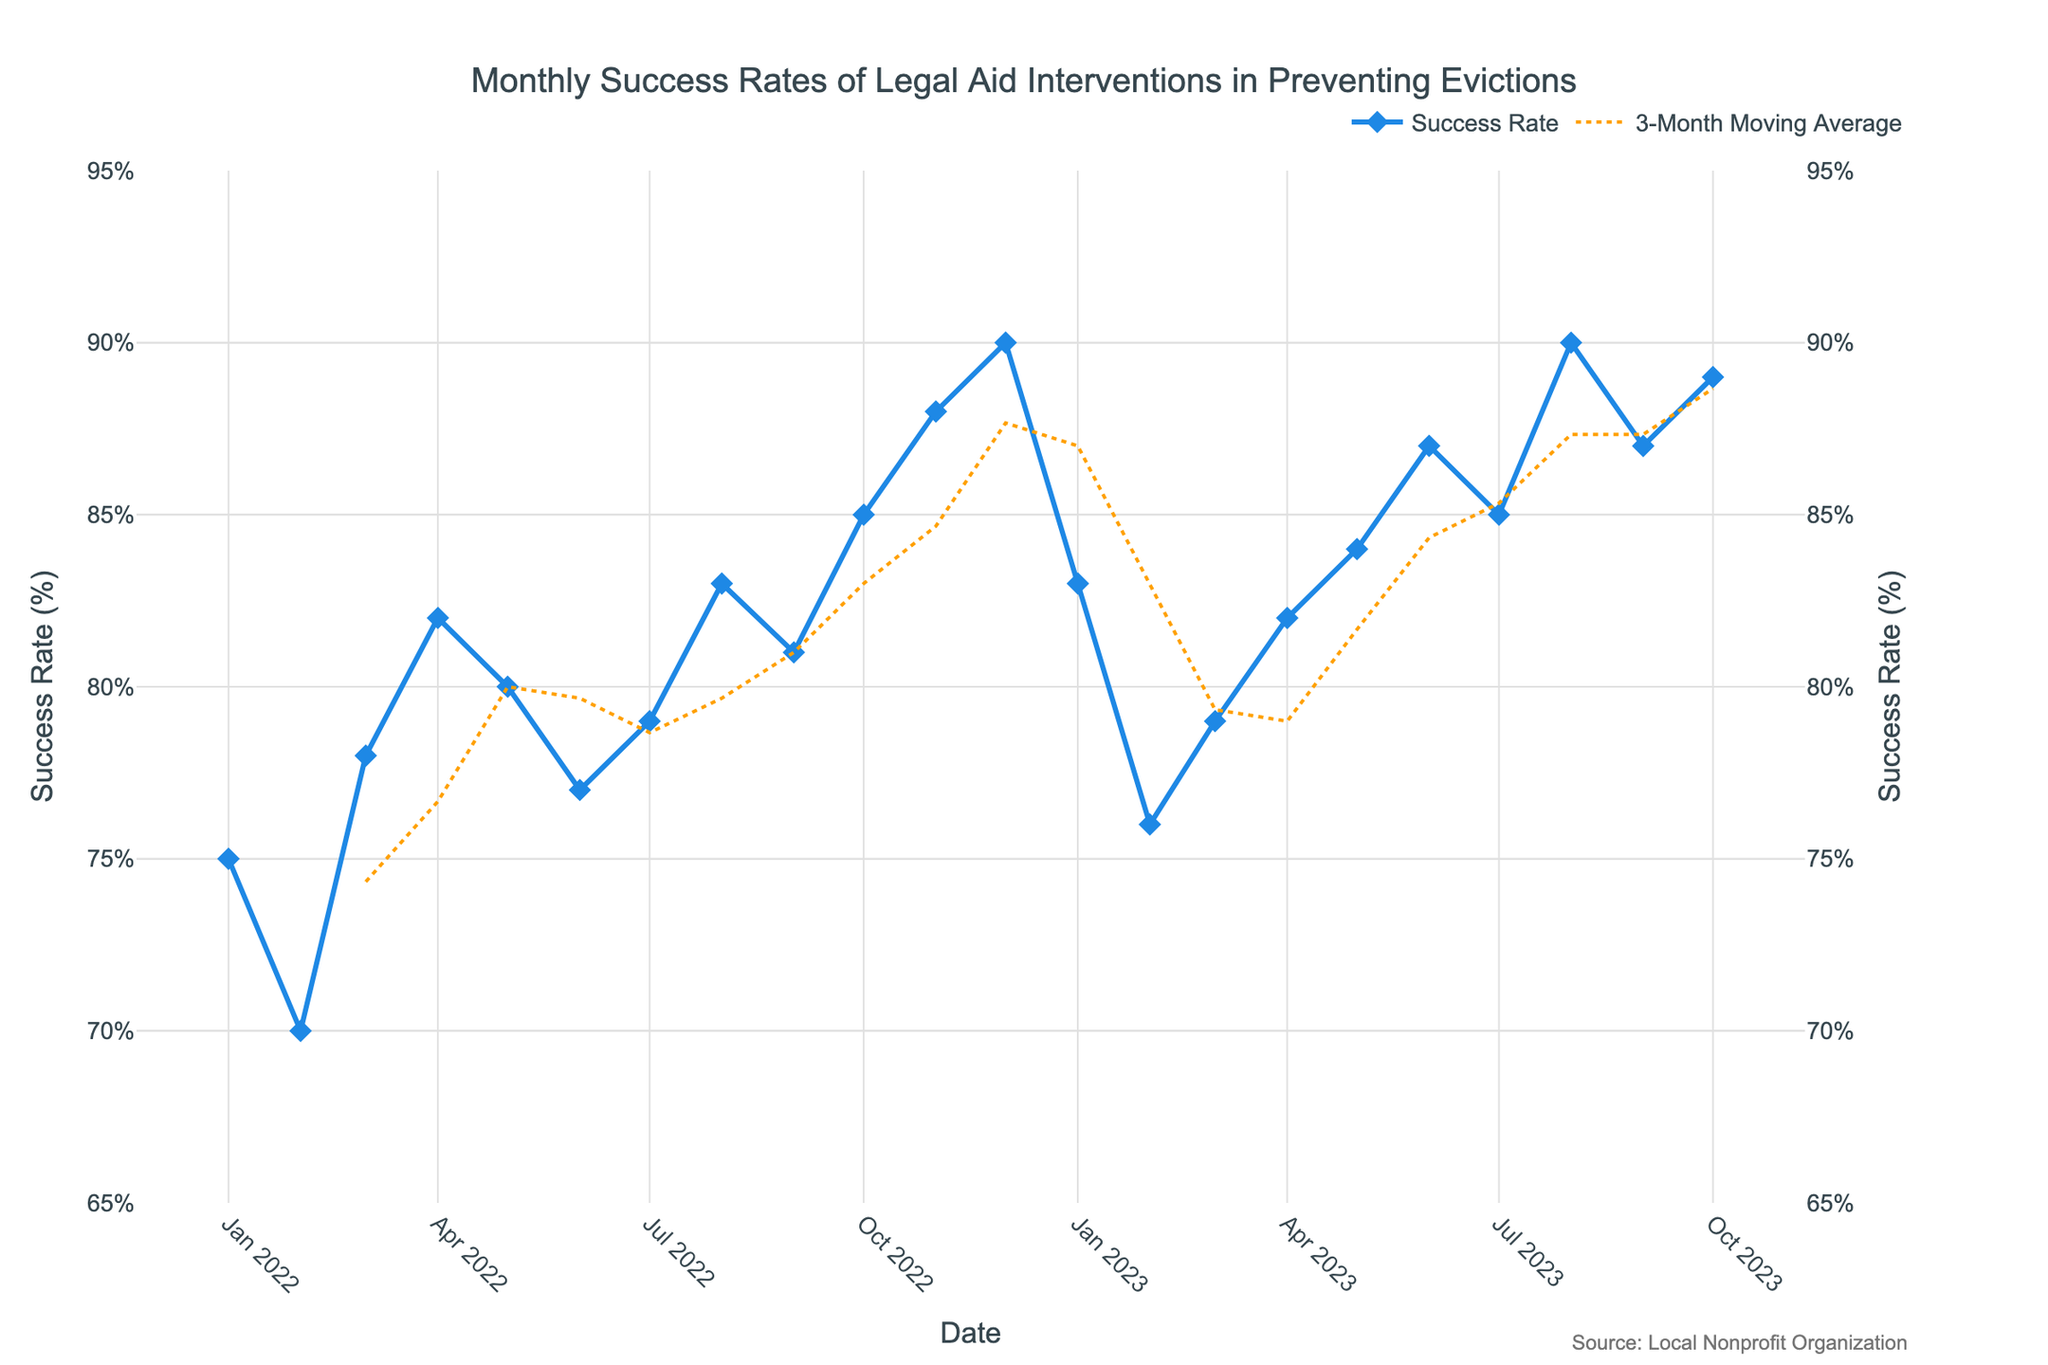What is the title of the plot? The title of the plot is displayed at the top and it reads "Monthly Success Rates of Legal Aid Interventions in Preventing Evictions".
Answer: Monthly Success Rates of Legal Aid Interventions in Preventing Evictions What is the success rate in January 2022? By looking at the data points in the plot, the success rate for January 2022 is marked at 75%.
Answer: 75% During which month in 2022 did the success rate first reach 80%? Observing the plotted data points, the success rate first reached 80% in May 2022.
Answer: May 2022 Which month had the highest success rate in 2022? Among the data points for 2022, December has the highest success rate at 90%.
Answer: December 2022 What is the 3-month moving average trend at the beginning of 2023? By following the dashed line representing the 3-month moving average, it shows a decreasing trend at the beginning of 2023 from January to February.
Answer: Decreasing What is the difference in success rate between December 2022 and January 2023? The success rate in December 2022 is 90% and in January 2023 it is 83%. The difference is 90% - 83% = 7%.
Answer: 7% Which month in 2023 showed the success rate returning and then exceeding the previous peak in December 2022? Observing the trend, August 2023 has a success rate of 90% which matches the previous peak in December 2022 and subsequent months exceed this value.
Answer: August 2023 How does the success rate in October 2023 compare to October 2022? The success rate for October 2023 is 89%, whereas for October 2022 it is 85%. Thus, the 2023 rate is higher by 4%.
Answer: 89% is higher by 4% Does the 3-month moving average ever go above 85%? By checking the dashed line for the 3-month moving average, it does go above 85% multiple times, for instance in the later months of 2023.
Answer: Yes When did the success rate drop significantly in 2023? The plot shows a noticeable drop in the success rate from January 2023 to February 2023, dropping from 83% to 76%.
Answer: February 2023 